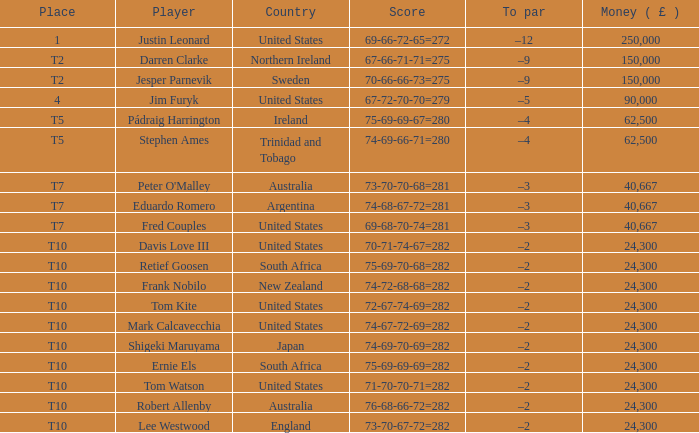Can you tell me lee westwood's score? 73-70-67-72=282. Could you parse the entire table as a dict? {'header': ['Place', 'Player', 'Country', 'Score', 'To par', 'Money ( £ )'], 'rows': [['1', 'Justin Leonard', 'United States', '69-66-72-65=272', '–12', '250,000'], ['T2', 'Darren Clarke', 'Northern Ireland', '67-66-71-71=275', '–9', '150,000'], ['T2', 'Jesper Parnevik', 'Sweden', '70-66-66-73=275', '–9', '150,000'], ['4', 'Jim Furyk', 'United States', '67-72-70-70=279', '–5', '90,000'], ['T5', 'Pádraig Harrington', 'Ireland', '75-69-69-67=280', '–4', '62,500'], ['T5', 'Stephen Ames', 'Trinidad and Tobago', '74-69-66-71=280', '–4', '62,500'], ['T7', "Peter O'Malley", 'Australia', '73-70-70-68=281', '–3', '40,667'], ['T7', 'Eduardo Romero', 'Argentina', '74-68-67-72=281', '–3', '40,667'], ['T7', 'Fred Couples', 'United States', '69-68-70-74=281', '–3', '40,667'], ['T10', 'Davis Love III', 'United States', '70-71-74-67=282', '–2', '24,300'], ['T10', 'Retief Goosen', 'South Africa', '75-69-70-68=282', '–2', '24,300'], ['T10', 'Frank Nobilo', 'New Zealand', '74-72-68-68=282', '–2', '24,300'], ['T10', 'Tom Kite', 'United States', '72-67-74-69=282', '–2', '24,300'], ['T10', 'Mark Calcavecchia', 'United States', '74-67-72-69=282', '–2', '24,300'], ['T10', 'Shigeki Maruyama', 'Japan', '74-69-70-69=282', '–2', '24,300'], ['T10', 'Ernie Els', 'South Africa', '75-69-69-69=282', '–2', '24,300'], ['T10', 'Tom Watson', 'United States', '71-70-70-71=282', '–2', '24,300'], ['T10', 'Robert Allenby', 'Australia', '76-68-66-72=282', '–2', '24,300'], ['T10', 'Lee Westwood', 'England', '73-70-67-72=282', '–2', '24,300']]} 